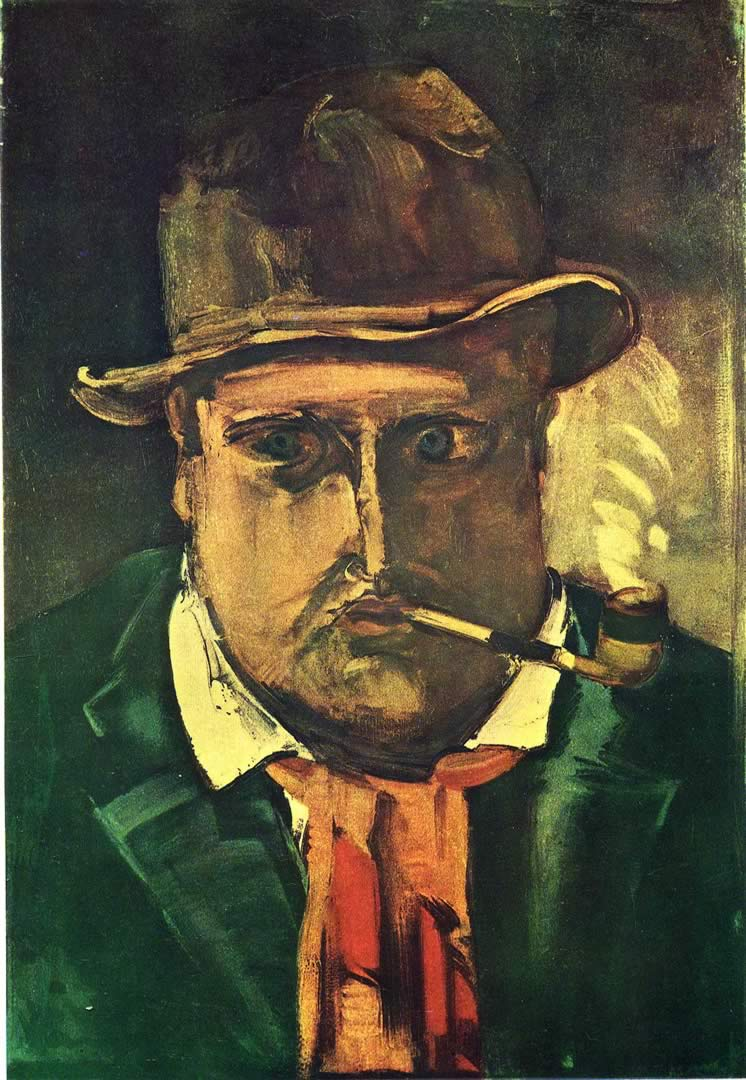Can you describe the main features of this image for me? The image is an evocative oil painting that vividly captures the essence of a man in an expressionist style. The man, wears a distinctive hat, and is seen thoughtfully smoking a pipe. The artist skillfully employs a palette dominated by dark greens and browns, which are intriguingly punctuated with occasional dashes of red and yellow accents, adding depth and contrast to the composition. The man's face and attire are depicted with intentional distortion and exaggeration, which are hallmark traits of the expressionist art genre. This style beautifully conveys intense emotions and psychological depth. The painting likely originates from the early 20th century, a period when expressionism was flourishing. The overall composition, with its bold use of color and form, strongly suggests its categorization within the expressionist art movement. 